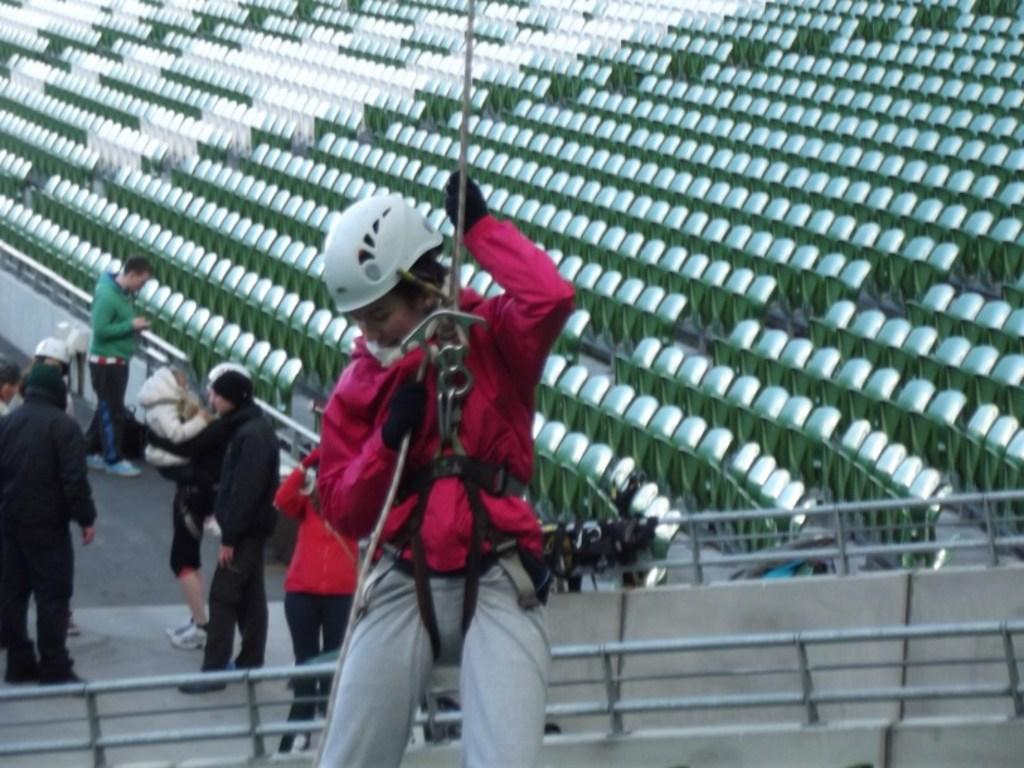What are the people in the image wearing? The people in the image are wearing clothes. What can be seen at the bottom of the image? There are safety barriers at the bottom of the image. What is located in the middle of the image? There are seats in the middle of the image. What type of stitch is used to hold the plastic together in the image? There is no plastic present in the image, so it is not possible to determine the type of stitch used. 